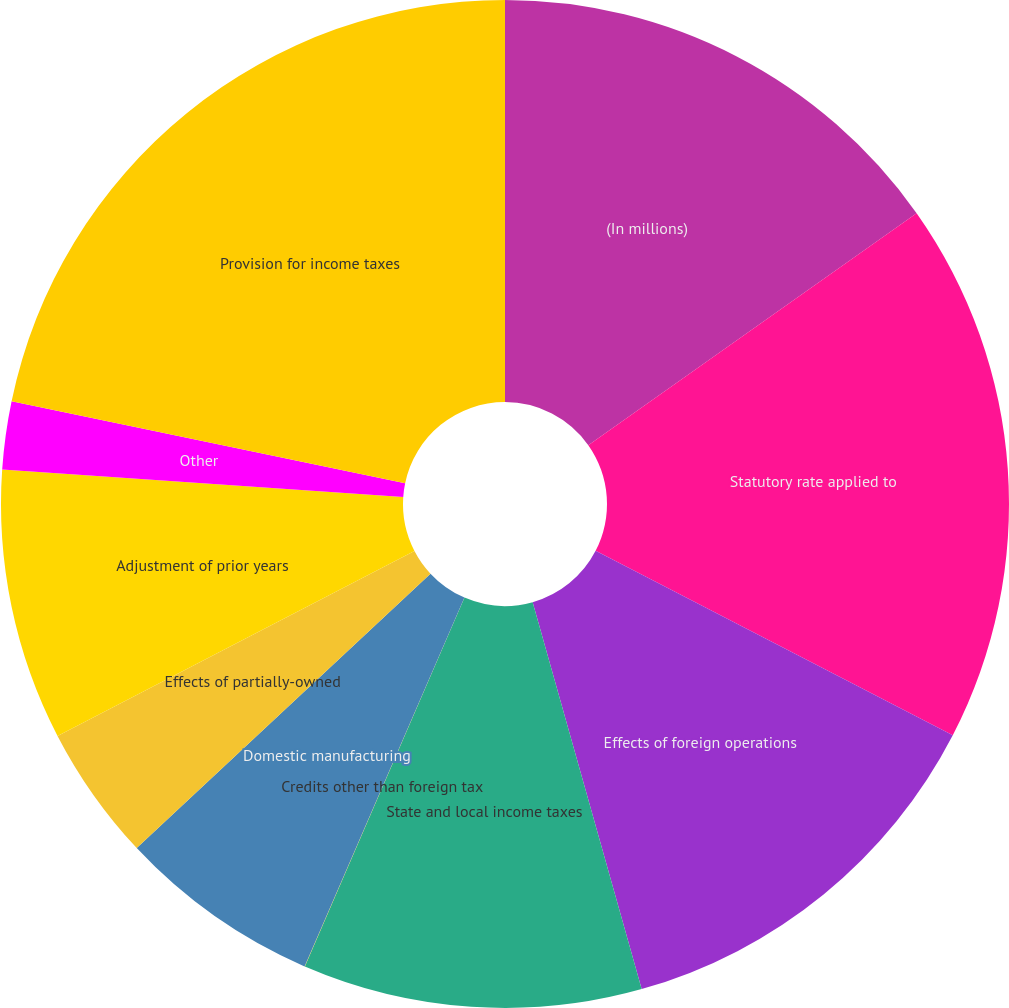Convert chart. <chart><loc_0><loc_0><loc_500><loc_500><pie_chart><fcel>(In millions)<fcel>Statutory rate applied to<fcel>Effects of foreign operations<fcel>State and local income taxes<fcel>Credits other than foreign tax<fcel>Domestic manufacturing<fcel>Effects of partially-owned<fcel>Adjustment of prior years<fcel>Other<fcel>Provision for income taxes<nl><fcel>15.21%<fcel>17.38%<fcel>13.04%<fcel>10.87%<fcel>0.01%<fcel>6.53%<fcel>4.35%<fcel>8.7%<fcel>2.18%<fcel>21.73%<nl></chart> 